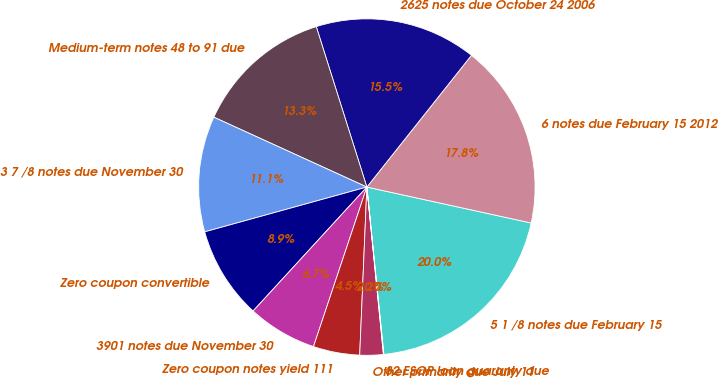<chart> <loc_0><loc_0><loc_500><loc_500><pie_chart><fcel>5 1 /8 notes due February 15<fcel>6 notes due February 15 2012<fcel>2625 notes due October 24 2006<fcel>Medium-term notes 48 to 91 due<fcel>3 7 /8 notes due November 30<fcel>Zero coupon convertible<fcel>3901 notes due November 30<fcel>Zero coupon notes yield 111<fcel>Other primarily due July 11<fcel>82 ESOP loan guaranty due<nl><fcel>19.96%<fcel>17.75%<fcel>15.54%<fcel>13.32%<fcel>11.11%<fcel>8.89%<fcel>6.68%<fcel>4.46%<fcel>2.25%<fcel>0.04%<nl></chart> 